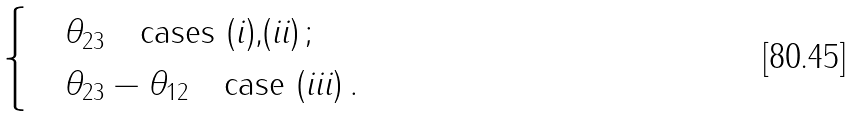Convert formula to latex. <formula><loc_0><loc_0><loc_500><loc_500>\begin{cases} \quad \theta _ { 2 3 } \quad \text {cases (\emph{i}),(\emph{ii})} \, ; \\ \quad \theta _ { 2 3 } - \theta _ { 1 2 } \quad \text {case (\emph{iii})} \, . \end{cases}</formula> 